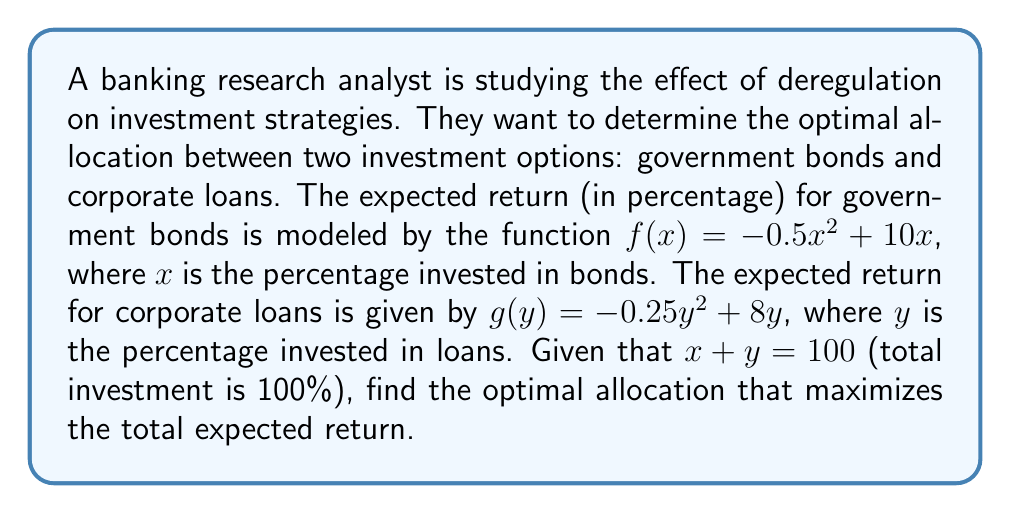Give your solution to this math problem. Let's approach this step-by-step:

1) The total expected return is the sum of returns from both investments:
   $R(x) = f(x) + g(y)$
   $R(x) = (-0.5x^2 + 10x) + (-0.25y^2 + 8y)$

2) We know that $x + y = 100$, so $y = 100 - x$. Let's substitute this:
   $R(x) = (-0.5x^2 + 10x) + (-0.25(100-x)^2 + 8(100-x))$

3) Expand the equation:
   $R(x) = -0.5x^2 + 10x - 0.25(10000 - 200x + x^2) + 800 - 8x$
   $R(x) = -0.5x^2 + 10x - 2500 + 50x - 0.25x^2 + 800 - 8x$
   $R(x) = -0.75x^2 + 52x - 1700$

4) To find the maximum, we need to find where the derivative equals zero:
   $R'(x) = -1.5x + 52$
   $0 = -1.5x + 52$
   $1.5x = 52$
   $x = 34.67$

5) This critical point is a maximum because the second derivative is negative:
   $R''(x) = -1.5 < 0$

6) Since $x + y = 100$, we can find $y$:
   $y = 100 - 34.67 = 65.33$

7) To verify this is within the domain, note that both $x$ and $y$ are between 0 and 100.
Answer: The optimal allocation is approximately 34.67% in government bonds and 65.33% in corporate loans. 